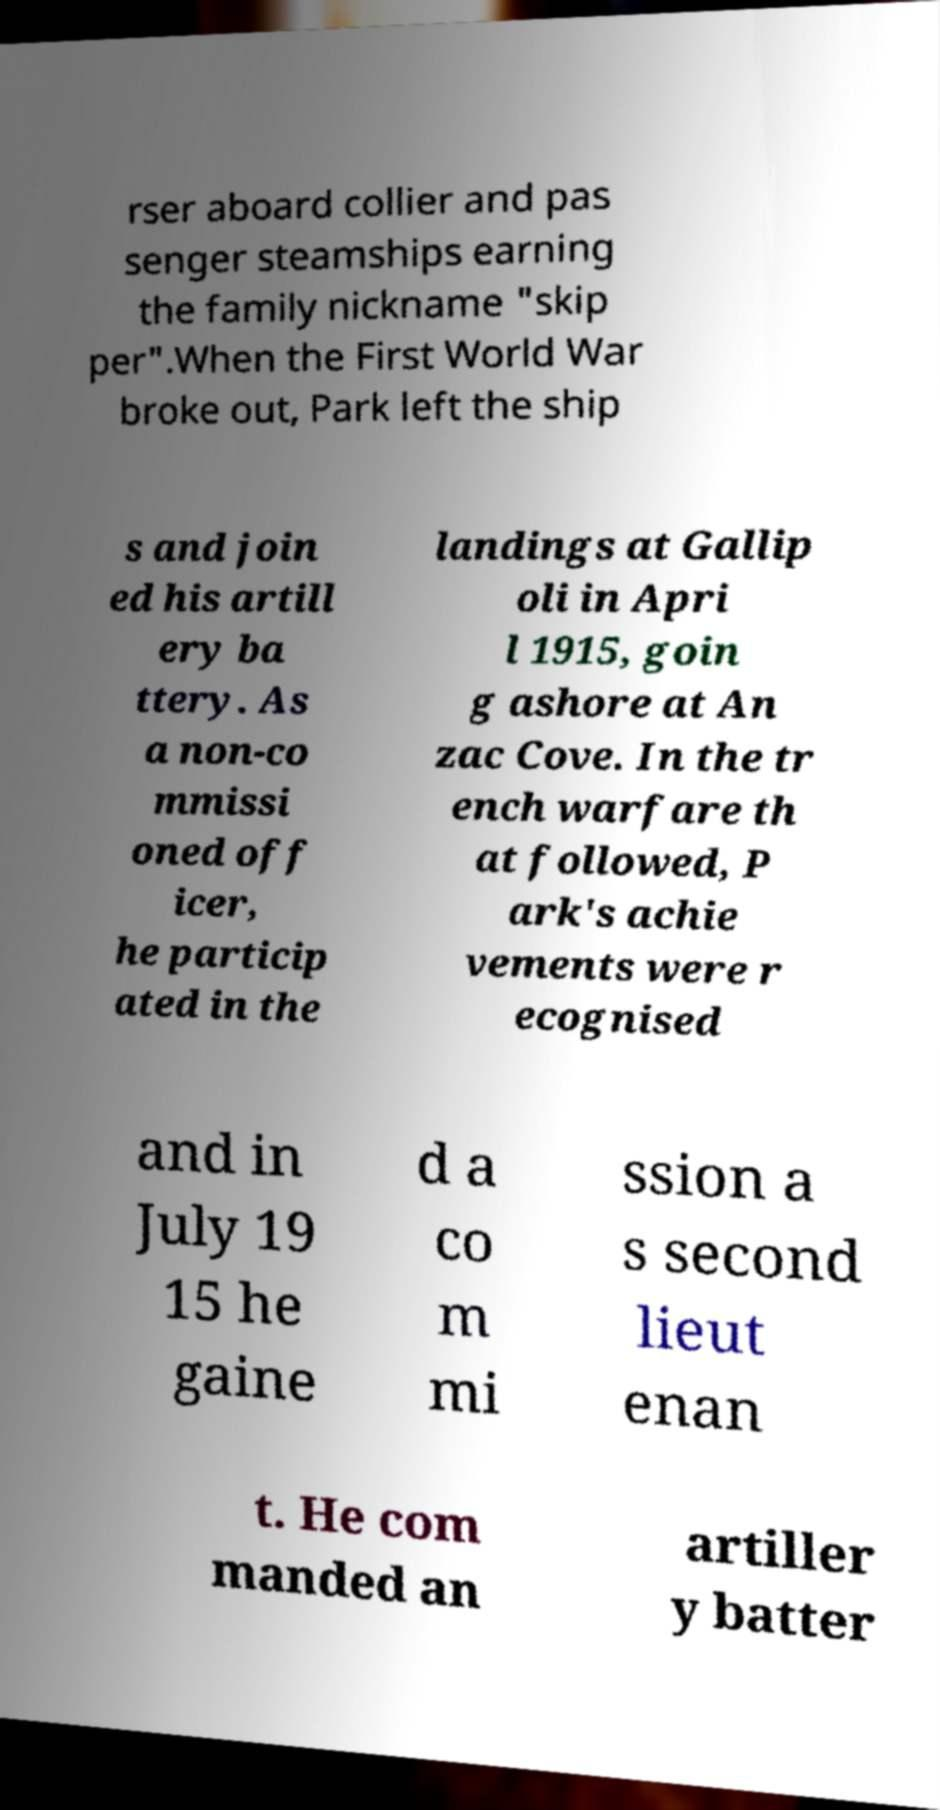Could you assist in decoding the text presented in this image and type it out clearly? rser aboard collier and pas senger steamships earning the family nickname "skip per".When the First World War broke out, Park left the ship s and join ed his artill ery ba ttery. As a non-co mmissi oned off icer, he particip ated in the landings at Gallip oli in Apri l 1915, goin g ashore at An zac Cove. In the tr ench warfare th at followed, P ark's achie vements were r ecognised and in July 19 15 he gaine d a co m mi ssion a s second lieut enan t. He com manded an artiller y batter 